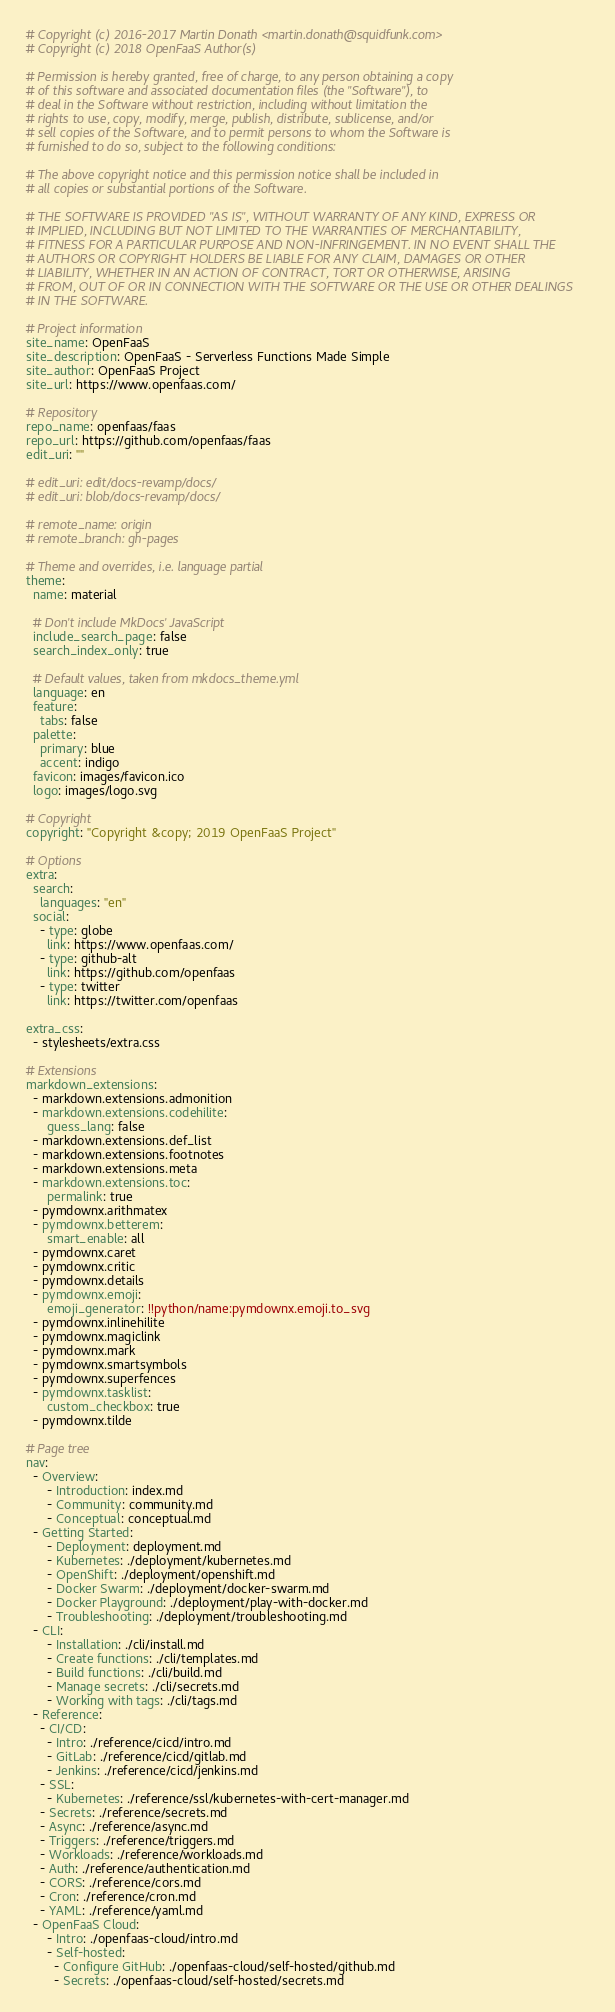<code> <loc_0><loc_0><loc_500><loc_500><_YAML_># Copyright (c) 2016-2017 Martin Donath <martin.donath@squidfunk.com>
# Copyright (c) 2018 OpenFaaS Author(s)

# Permission is hereby granted, free of charge, to any person obtaining a copy
# of this software and associated documentation files (the "Software"), to
# deal in the Software without restriction, including without limitation the
# rights to use, copy, modify, merge, publish, distribute, sublicense, and/or
# sell copies of the Software, and to permit persons to whom the Software is
# furnished to do so, subject to the following conditions:

# The above copyright notice and this permission notice shall be included in
# all copies or substantial portions of the Software.

# THE SOFTWARE IS PROVIDED "AS IS", WITHOUT WARRANTY OF ANY KIND, EXPRESS OR
# IMPLIED, INCLUDING BUT NOT LIMITED TO THE WARRANTIES OF MERCHANTABILITY,
# FITNESS FOR A PARTICULAR PURPOSE AND NON-INFRINGEMENT. IN NO EVENT SHALL THE
# AUTHORS OR COPYRIGHT HOLDERS BE LIABLE FOR ANY CLAIM, DAMAGES OR OTHER
# LIABILITY, WHETHER IN AN ACTION OF CONTRACT, TORT OR OTHERWISE, ARISING
# FROM, OUT OF OR IN CONNECTION WITH THE SOFTWARE OR THE USE OR OTHER DEALINGS
# IN THE SOFTWARE.

# Project information
site_name: OpenFaaS
site_description: OpenFaaS - Serverless Functions Made Simple
site_author: OpenFaaS Project
site_url: https://www.openfaas.com/

# Repository
repo_name: openfaas/faas
repo_url: https://github.com/openfaas/faas
edit_uri: ""

# edit_uri: edit/docs-revamp/docs/
# edit_uri: blob/docs-revamp/docs/

# remote_name: origin
# remote_branch: gh-pages

# Theme and overrides, i.e. language partial
theme:
  name: material

  # Don't include MkDocs' JavaScript
  include_search_page: false
  search_index_only: true

  # Default values, taken from mkdocs_theme.yml
  language: en
  feature:
    tabs: false
  palette:
    primary: blue
    accent: indigo
  favicon: images/favicon.ico
  logo: images/logo.svg

# Copyright
copyright: "Copyright &copy; 2019 OpenFaaS Project"

# Options
extra:
  search:
    languages: "en"
  social:
    - type: globe
      link: https://www.openfaas.com/
    - type: github-alt
      link: https://github.com/openfaas
    - type: twitter
      link: https://twitter.com/openfaas

extra_css:
  - stylesheets/extra.css

# Extensions
markdown_extensions:
  - markdown.extensions.admonition
  - markdown.extensions.codehilite:
      guess_lang: false
  - markdown.extensions.def_list
  - markdown.extensions.footnotes
  - markdown.extensions.meta
  - markdown.extensions.toc:
      permalink: true
  - pymdownx.arithmatex
  - pymdownx.betterem:
      smart_enable: all
  - pymdownx.caret
  - pymdownx.critic
  - pymdownx.details
  - pymdownx.emoji:
      emoji_generator: !!python/name:pymdownx.emoji.to_svg
  - pymdownx.inlinehilite
  - pymdownx.magiclink
  - pymdownx.mark
  - pymdownx.smartsymbols
  - pymdownx.superfences
  - pymdownx.tasklist:
      custom_checkbox: true
  - pymdownx.tilde

# Page tree
nav:
  - Overview:
      - Introduction: index.md
      - Community: community.md
      - Conceptual: conceptual.md
  - Getting Started:
      - Deployment: deployment.md
      - Kubernetes: ./deployment/kubernetes.md
      - OpenShift: ./deployment/openshift.md
      - Docker Swarm: ./deployment/docker-swarm.md
      - Docker Playground: ./deployment/play-with-docker.md
      - Troubleshooting: ./deployment/troubleshooting.md
  - CLI:
      - Installation: ./cli/install.md
      - Create functions: ./cli/templates.md
      - Build functions: ./cli/build.md
      - Manage secrets: ./cli/secrets.md
      - Working with tags: ./cli/tags.md
  - Reference:
    - CI/CD:
      - Intro: ./reference/cicd/intro.md
      - GitLab: ./reference/cicd/gitlab.md
      - Jenkins: ./reference/cicd/jenkins.md
    - SSL:
      - Kubernetes: ./reference/ssl/kubernetes-with-cert-manager.md
    - Secrets: ./reference/secrets.md
    - Async: ./reference/async.md
    - Triggers: ./reference/triggers.md
    - Workloads: ./reference/workloads.md
    - Auth: ./reference/authentication.md
    - CORS: ./reference/cors.md
    - Cron: ./reference/cron.md
    - YAML: ./reference/yaml.md
  - OpenFaaS Cloud:
      - Intro: ./openfaas-cloud/intro.md
      - Self-hosted:
        - Configure GitHub: ./openfaas-cloud/self-hosted/github.md
        - Secrets: ./openfaas-cloud/self-hosted/secrets.md</code> 